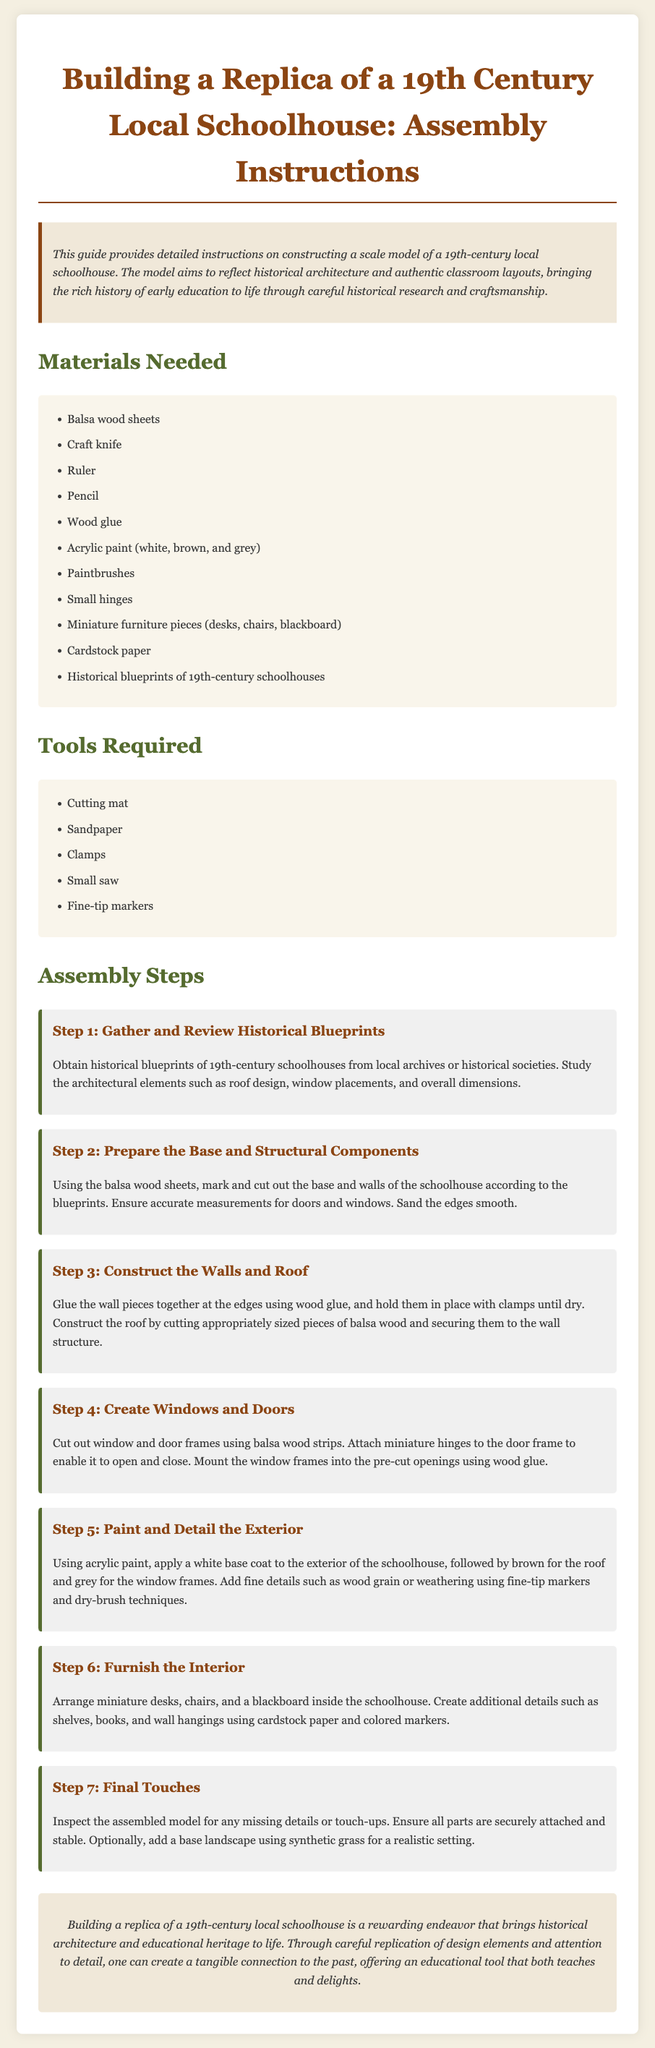What materials are needed? The list of materials required for building the replica includes items such as balsa wood sheets, craft knife, ruler, and more.
Answer: Balsa wood sheets, craft knife, ruler, pencil, wood glue, acrylic paint, paintbrushes, small hinges, miniature furniture pieces, cardstock paper, historical blueprints What tool is required for cutting? The tools required for assembly specifically include items such as cutting mats and small saws.
Answer: Small saw What step involves creating windows and doors? The step where windows and doors are created is clearly detailed in the assembly steps section.
Answer: Step 4: Create Windows and Doors How many assembly steps are there? The number of assembly steps outlined in the document indicates the stages to complete the model.
Answer: Seven What is the purpose of historical blueprints in the assembly? The historical blueprints serve as a guide for accurate architectural replication during the assembly.
Answer: Study architectural elements What color is applied to the exterior of the schoolhouse? The specific color mentioned for the exterior of the schoolhouse in Step 5 is highlighted in the painting stage.
Answer: White What is advised for final touches? The document suggests inspecting the model and adding a base landscape for realism during the final touch phase.
Answer: Inspect the assembled model In which section can the introductory paragraph be found? The introduction paragraph is located at the beginning part of the document, preceding the materials and tools sections.
Answer: Intro section 